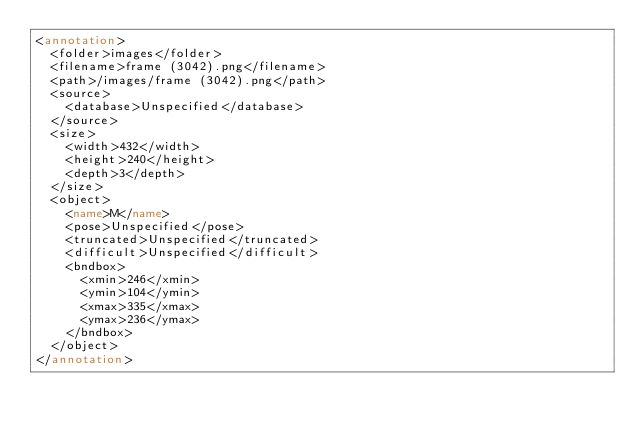<code> <loc_0><loc_0><loc_500><loc_500><_XML_><annotation>
	<folder>images</folder>
	<filename>frame (3042).png</filename>
	<path>/images/frame (3042).png</path>
	<source>
		<database>Unspecified</database>
	</source>
	<size>
		<width>432</width>
		<height>240</height>
		<depth>3</depth>
	</size>
	<object>
		<name>M</name>
		<pose>Unspecified</pose>
		<truncated>Unspecified</truncated>
		<difficult>Unspecified</difficult>
		<bndbox>
			<xmin>246</xmin>
			<ymin>104</ymin>
			<xmax>335</xmax>
			<ymax>236</ymax>
		</bndbox>
	</object>
</annotation></code> 